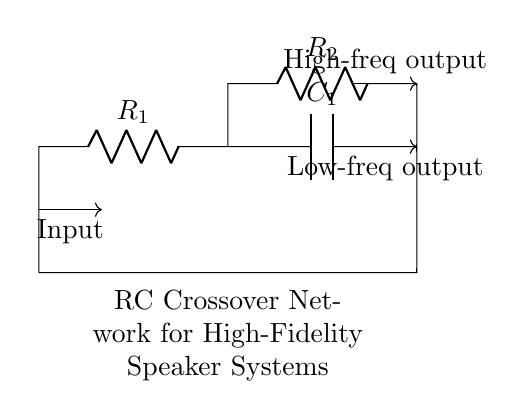What is the value of resistance R1? The value of resistance R1 is denoted as R1 in the diagram, indicating it's a variable component.
Answer: R1 What is the function of capacitor C1? Capacitor C1 is used to pass high-frequency signals while blocking low-frequency signals. This is a key function in crossover networks.
Answer: Pass high frequencies How many resistors are present in this circuit? There are two resistors R1 and R2 in the circuit. This is observed from the labels attached to the circuit diagram.
Answer: Two What type of circuit is this? This circuit is an RC (Resistor-Capacitor) circuit designed specifically for audio crossover networks. This can be identified from the configuration and the components used.
Answer: RC Circuit What does the output from point C represent? The output from point C is the low-frequency output, as indicated by the label below it in the diagram. This represents the signal passed from the capacitor.
Answer: Low-frequency output How do resistors R1 and R2 interact in the circuit? Resistors R1 and R2 are in a configuration where R1 is in series with the combination of C1, while R2 provides a high-frequency path. Their arrangement helps segment audio frequencies for speakers.
Answer: Series and parallel configuration What is indicated by the arrows on the input and output? The arrows signify the direction of signal flow, with the input arrow showing where the signal enters and the output arrows indicating where the signals exit the circuit. This helps one understand the operational flow.
Answer: Signal flow direction 